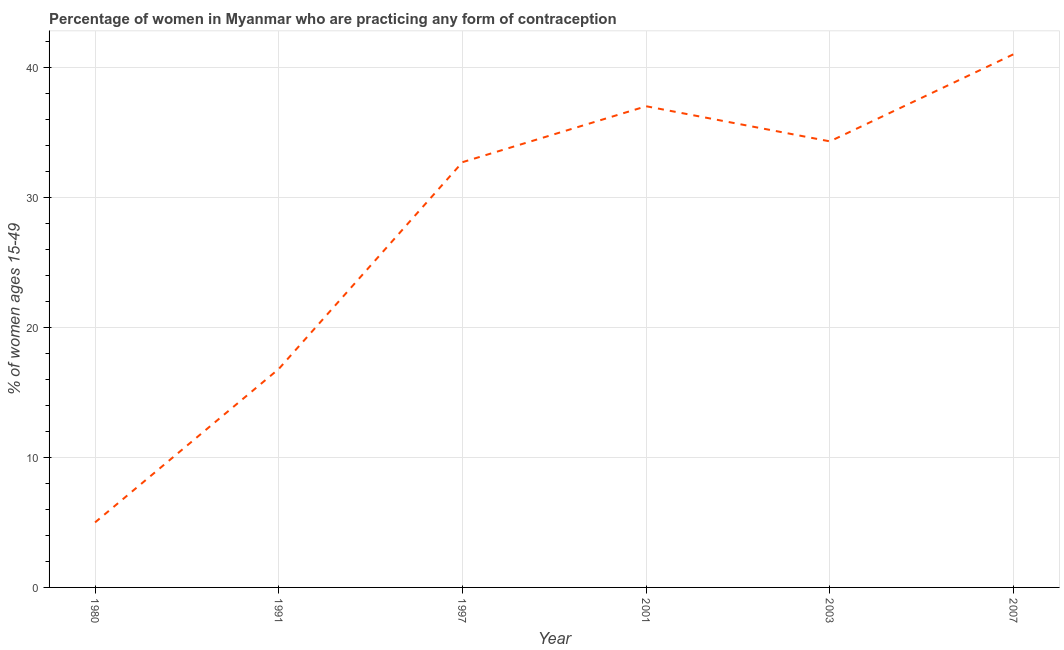What is the contraceptive prevalence in 1997?
Ensure brevity in your answer.  32.7. Across all years, what is the maximum contraceptive prevalence?
Your answer should be compact. 41. In which year was the contraceptive prevalence maximum?
Provide a short and direct response. 2007. What is the sum of the contraceptive prevalence?
Provide a short and direct response. 166.8. What is the difference between the contraceptive prevalence in 2003 and 2007?
Provide a succinct answer. -6.7. What is the average contraceptive prevalence per year?
Offer a very short reply. 27.8. What is the median contraceptive prevalence?
Give a very brief answer. 33.5. In how many years, is the contraceptive prevalence greater than 20 %?
Make the answer very short. 4. Do a majority of the years between 2001 and 2003 (inclusive) have contraceptive prevalence greater than 36 %?
Give a very brief answer. No. What is the ratio of the contraceptive prevalence in 1991 to that in 2003?
Make the answer very short. 0.49. Is the difference between the contraceptive prevalence in 1991 and 2007 greater than the difference between any two years?
Ensure brevity in your answer.  No. Is the sum of the contraceptive prevalence in 1980 and 2003 greater than the maximum contraceptive prevalence across all years?
Keep it short and to the point. No. What is the difference between the highest and the lowest contraceptive prevalence?
Give a very brief answer. 36. In how many years, is the contraceptive prevalence greater than the average contraceptive prevalence taken over all years?
Provide a succinct answer. 4. Does the contraceptive prevalence monotonically increase over the years?
Keep it short and to the point. No. How many years are there in the graph?
Keep it short and to the point. 6. What is the difference between two consecutive major ticks on the Y-axis?
Your answer should be very brief. 10. What is the title of the graph?
Offer a very short reply. Percentage of women in Myanmar who are practicing any form of contraception. What is the label or title of the X-axis?
Give a very brief answer. Year. What is the label or title of the Y-axis?
Provide a succinct answer. % of women ages 15-49. What is the % of women ages 15-49 of 1980?
Offer a very short reply. 5. What is the % of women ages 15-49 of 1997?
Offer a terse response. 32.7. What is the % of women ages 15-49 in 2001?
Provide a short and direct response. 37. What is the % of women ages 15-49 in 2003?
Make the answer very short. 34.3. What is the % of women ages 15-49 in 2007?
Provide a succinct answer. 41. What is the difference between the % of women ages 15-49 in 1980 and 1991?
Provide a succinct answer. -11.8. What is the difference between the % of women ages 15-49 in 1980 and 1997?
Provide a short and direct response. -27.7. What is the difference between the % of women ages 15-49 in 1980 and 2001?
Offer a very short reply. -32. What is the difference between the % of women ages 15-49 in 1980 and 2003?
Keep it short and to the point. -29.3. What is the difference between the % of women ages 15-49 in 1980 and 2007?
Your response must be concise. -36. What is the difference between the % of women ages 15-49 in 1991 and 1997?
Your answer should be compact. -15.9. What is the difference between the % of women ages 15-49 in 1991 and 2001?
Your response must be concise. -20.2. What is the difference between the % of women ages 15-49 in 1991 and 2003?
Offer a terse response. -17.5. What is the difference between the % of women ages 15-49 in 1991 and 2007?
Your answer should be compact. -24.2. What is the difference between the % of women ages 15-49 in 1997 and 2003?
Offer a very short reply. -1.6. What is the difference between the % of women ages 15-49 in 1997 and 2007?
Make the answer very short. -8.3. What is the difference between the % of women ages 15-49 in 2001 and 2003?
Offer a very short reply. 2.7. What is the ratio of the % of women ages 15-49 in 1980 to that in 1991?
Your answer should be very brief. 0.3. What is the ratio of the % of women ages 15-49 in 1980 to that in 1997?
Provide a short and direct response. 0.15. What is the ratio of the % of women ages 15-49 in 1980 to that in 2001?
Your answer should be compact. 0.14. What is the ratio of the % of women ages 15-49 in 1980 to that in 2003?
Ensure brevity in your answer.  0.15. What is the ratio of the % of women ages 15-49 in 1980 to that in 2007?
Your answer should be compact. 0.12. What is the ratio of the % of women ages 15-49 in 1991 to that in 1997?
Provide a short and direct response. 0.51. What is the ratio of the % of women ages 15-49 in 1991 to that in 2001?
Give a very brief answer. 0.45. What is the ratio of the % of women ages 15-49 in 1991 to that in 2003?
Ensure brevity in your answer.  0.49. What is the ratio of the % of women ages 15-49 in 1991 to that in 2007?
Provide a short and direct response. 0.41. What is the ratio of the % of women ages 15-49 in 1997 to that in 2001?
Provide a short and direct response. 0.88. What is the ratio of the % of women ages 15-49 in 1997 to that in 2003?
Keep it short and to the point. 0.95. What is the ratio of the % of women ages 15-49 in 1997 to that in 2007?
Make the answer very short. 0.8. What is the ratio of the % of women ages 15-49 in 2001 to that in 2003?
Offer a terse response. 1.08. What is the ratio of the % of women ages 15-49 in 2001 to that in 2007?
Provide a succinct answer. 0.9. What is the ratio of the % of women ages 15-49 in 2003 to that in 2007?
Keep it short and to the point. 0.84. 